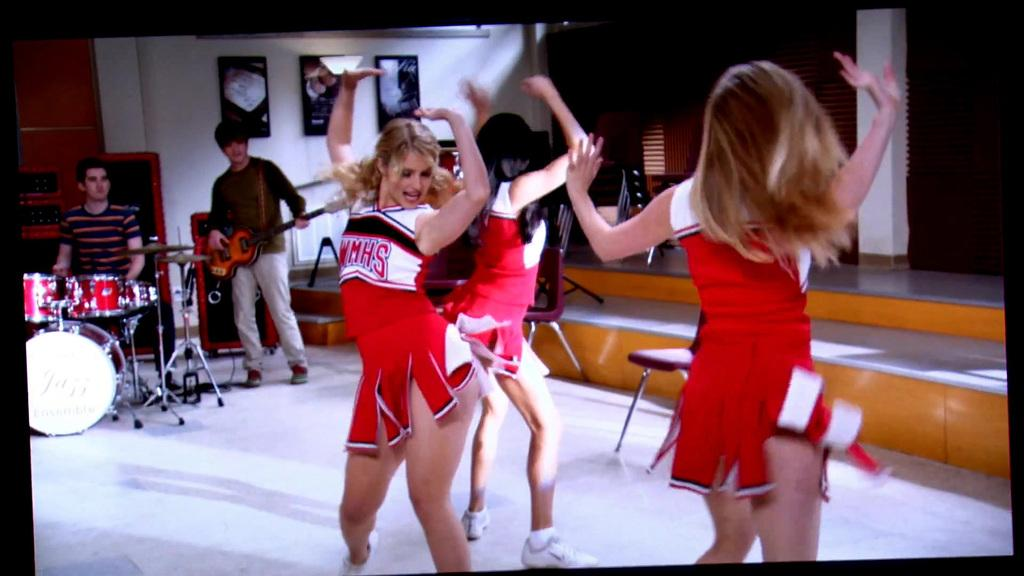<image>
Summarize the visual content of the image. The cheer leaders dancing together are from WHMS. 